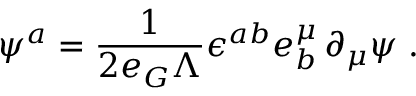<formula> <loc_0><loc_0><loc_500><loc_500>\psi ^ { a } = \frac { 1 } { 2 e _ { G } \Lambda } \epsilon ^ { a b } e _ { b } ^ { \mu } \, \partial _ { \mu } \psi \, .</formula> 